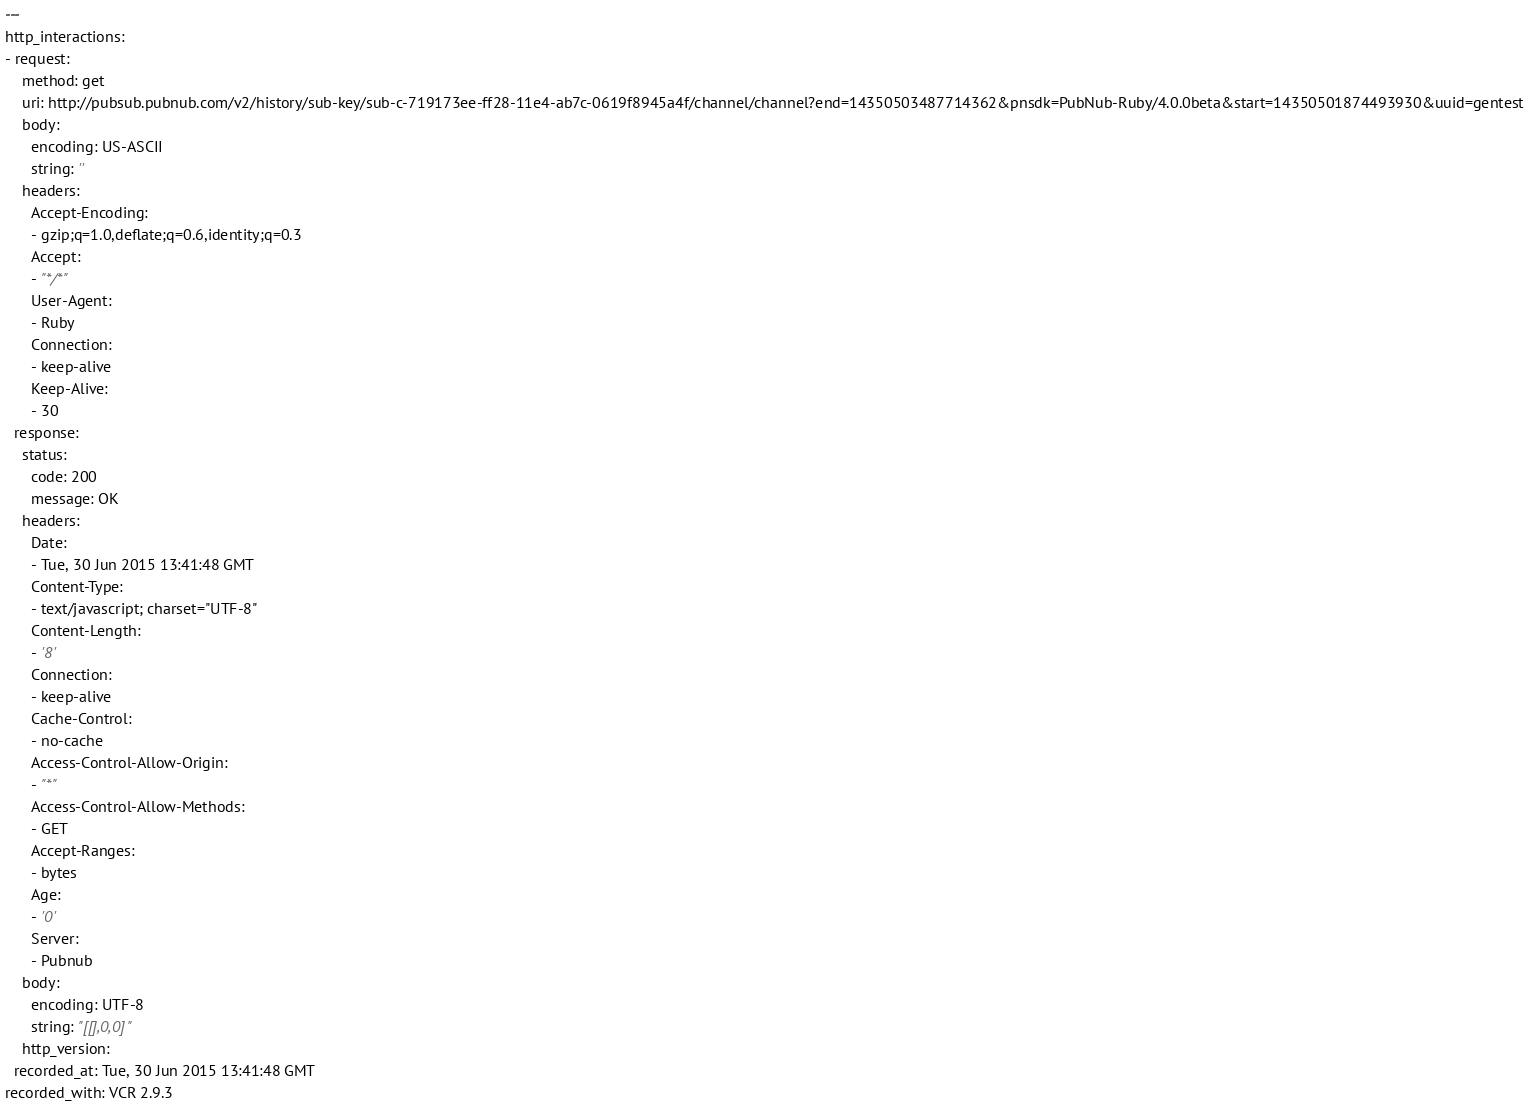Convert code to text. <code><loc_0><loc_0><loc_500><loc_500><_YAML_>---
http_interactions:
- request:
    method: get
    uri: http://pubsub.pubnub.com/v2/history/sub-key/sub-c-719173ee-ff28-11e4-ab7c-0619f8945a4f/channel/channel?end=14350503487714362&pnsdk=PubNub-Ruby/4.0.0beta&start=14350501874493930&uuid=gentest
    body:
      encoding: US-ASCII
      string: ''
    headers:
      Accept-Encoding:
      - gzip;q=1.0,deflate;q=0.6,identity;q=0.3
      Accept:
      - "*/*"
      User-Agent:
      - Ruby
      Connection:
      - keep-alive
      Keep-Alive:
      - 30
  response:
    status:
      code: 200
      message: OK
    headers:
      Date:
      - Tue, 30 Jun 2015 13:41:48 GMT
      Content-Type:
      - text/javascript; charset="UTF-8"
      Content-Length:
      - '8'
      Connection:
      - keep-alive
      Cache-Control:
      - no-cache
      Access-Control-Allow-Origin:
      - "*"
      Access-Control-Allow-Methods:
      - GET
      Accept-Ranges:
      - bytes
      Age:
      - '0'
      Server:
      - Pubnub
    body:
      encoding: UTF-8
      string: "[[],0,0]"
    http_version: 
  recorded_at: Tue, 30 Jun 2015 13:41:48 GMT
recorded_with: VCR 2.9.3
</code> 